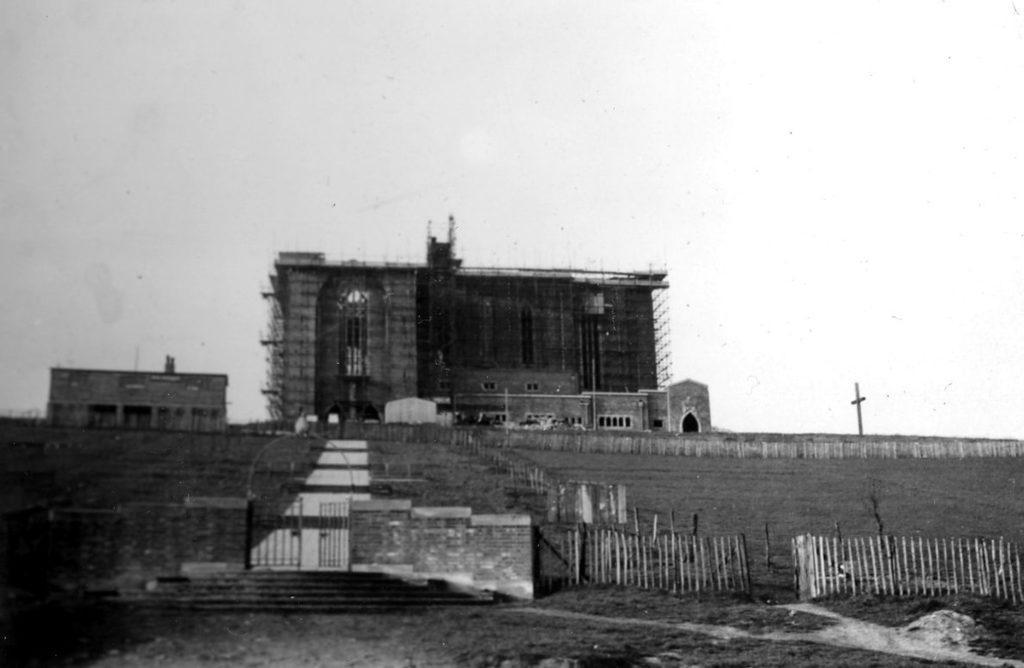How would you summarize this image in a sentence or two? In this picture we can see a building. There is a cross sign on the path. A gate and few stairs are visible. We can see wooden fencing and some grass is visible on the ground. 